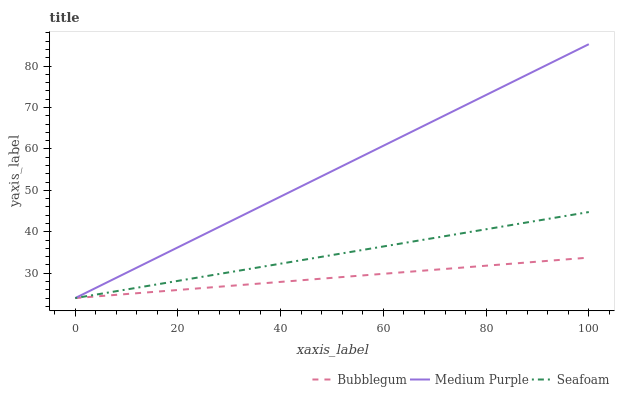Does Bubblegum have the minimum area under the curve?
Answer yes or no. Yes. Does Medium Purple have the maximum area under the curve?
Answer yes or no. Yes. Does Seafoam have the minimum area under the curve?
Answer yes or no. No. Does Seafoam have the maximum area under the curve?
Answer yes or no. No. Is Bubblegum the smoothest?
Answer yes or no. Yes. Is Medium Purple the roughest?
Answer yes or no. Yes. Is Seafoam the smoothest?
Answer yes or no. No. Is Seafoam the roughest?
Answer yes or no. No. Does Medium Purple have the lowest value?
Answer yes or no. Yes. Does Medium Purple have the highest value?
Answer yes or no. Yes. Does Seafoam have the highest value?
Answer yes or no. No. Does Medium Purple intersect Seafoam?
Answer yes or no. Yes. Is Medium Purple less than Seafoam?
Answer yes or no. No. Is Medium Purple greater than Seafoam?
Answer yes or no. No. 